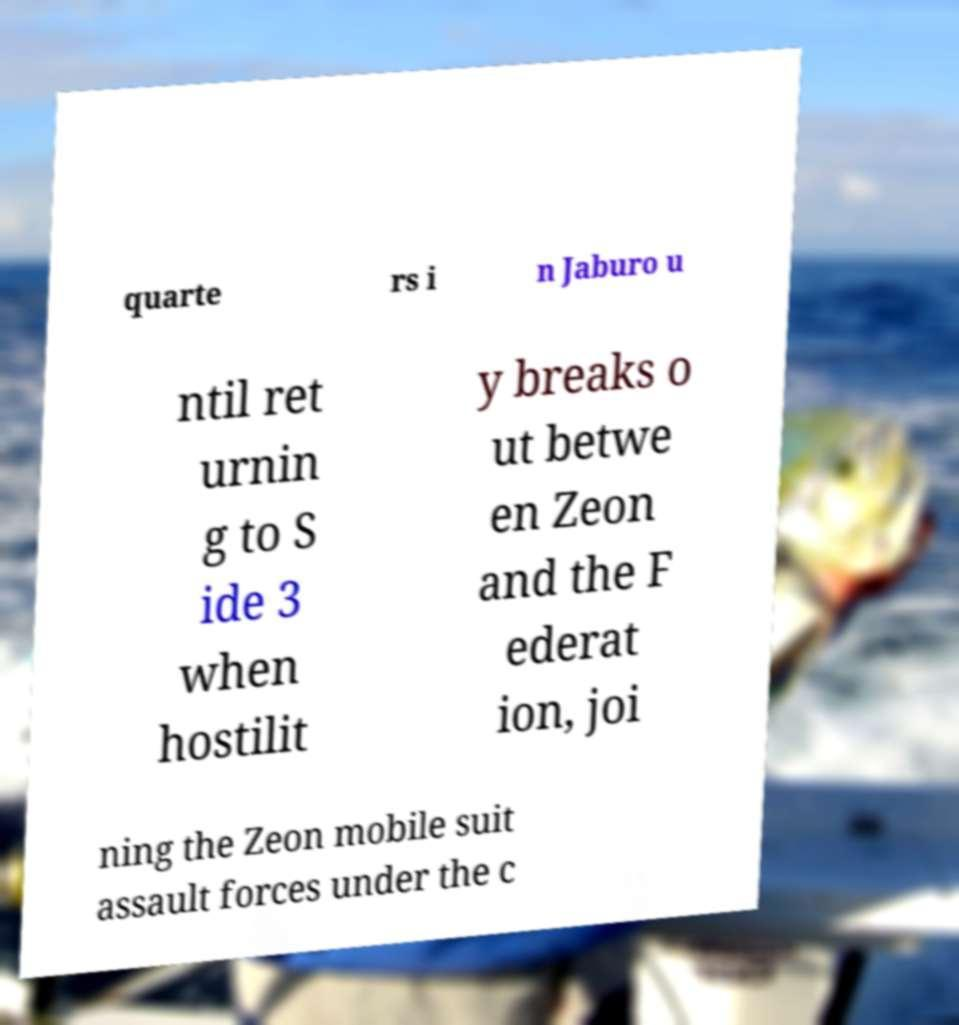I need the written content from this picture converted into text. Can you do that? quarte rs i n Jaburo u ntil ret urnin g to S ide 3 when hostilit y breaks o ut betwe en Zeon and the F ederat ion, joi ning the Zeon mobile suit assault forces under the c 